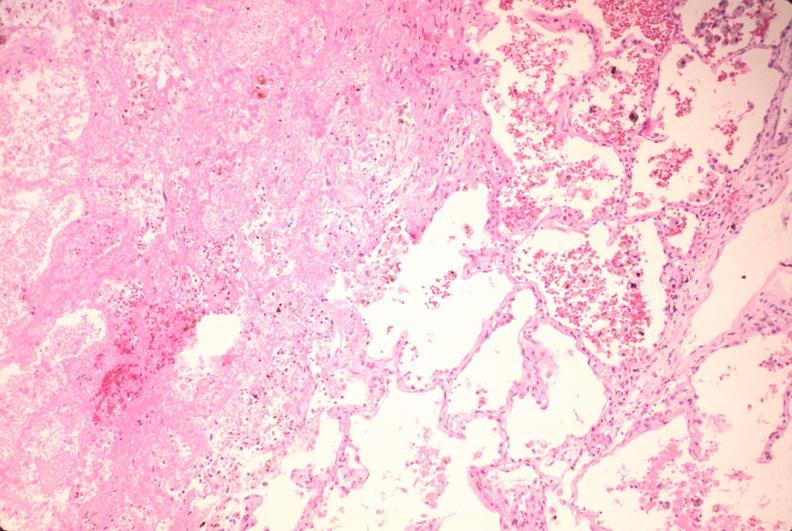s respiratory present?
Answer the question using a single word or phrase. Yes 